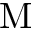Convert formula to latex. <formula><loc_0><loc_0><loc_500><loc_500>M</formula> 